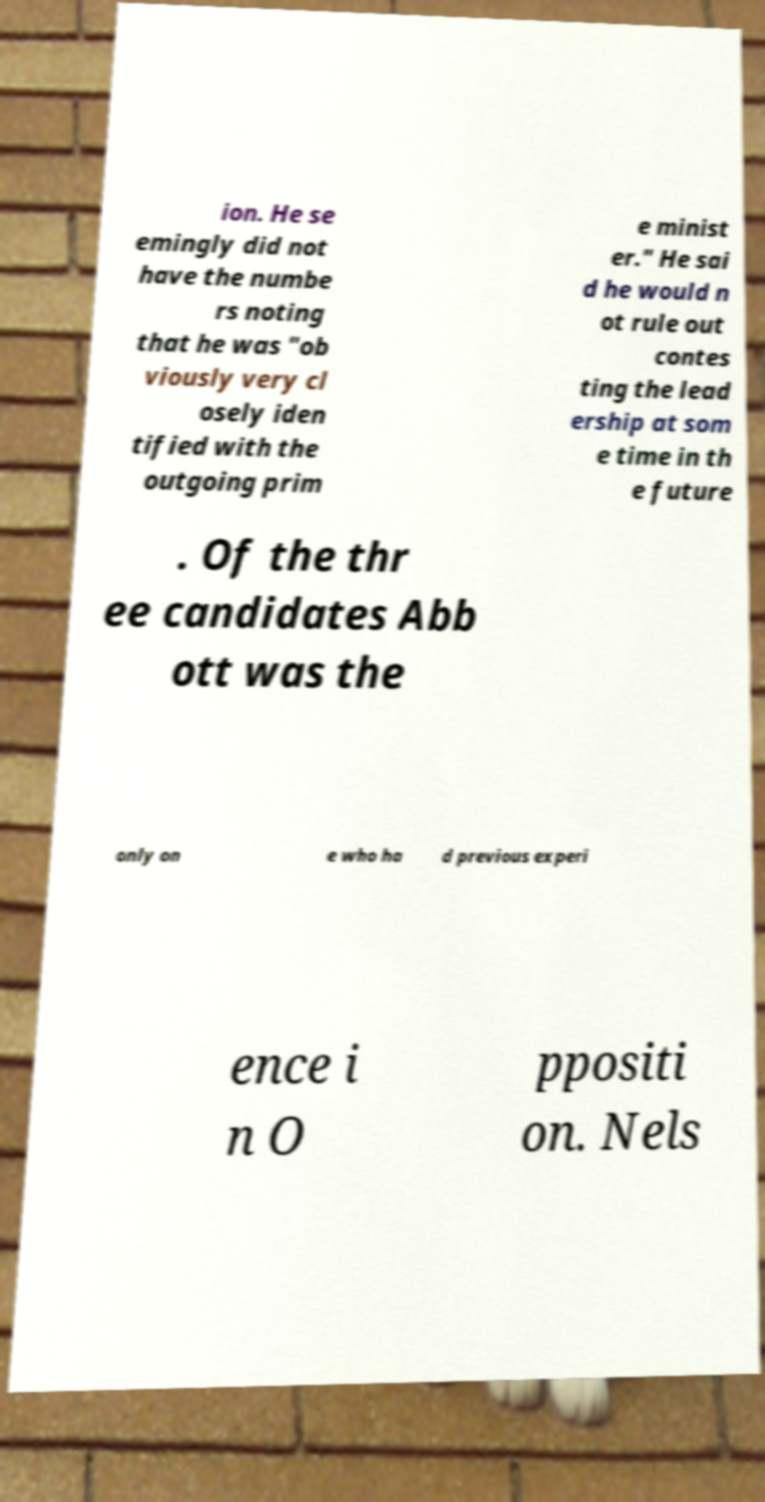Can you read and provide the text displayed in the image?This photo seems to have some interesting text. Can you extract and type it out for me? ion. He se emingly did not have the numbe rs noting that he was "ob viously very cl osely iden tified with the outgoing prim e minist er." He sai d he would n ot rule out contes ting the lead ership at som e time in th e future . Of the thr ee candidates Abb ott was the only on e who ha d previous experi ence i n O ppositi on. Nels 